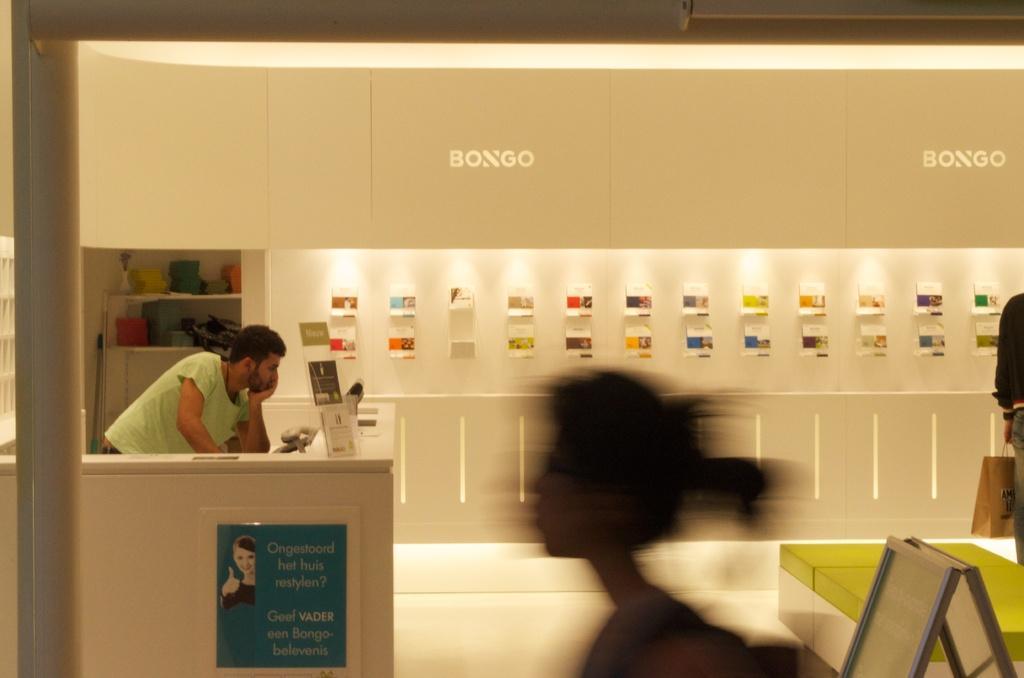Can you describe this image briefly? In this image we can see some objects attached to the wall. We can also see the lights. On the left there is a person standing in front of the counter and on the counter we can see some text bards and also the poster. We can also see a woman in the center. On the right there is a person holding the bag and standing. We can also see the text on the wall. 